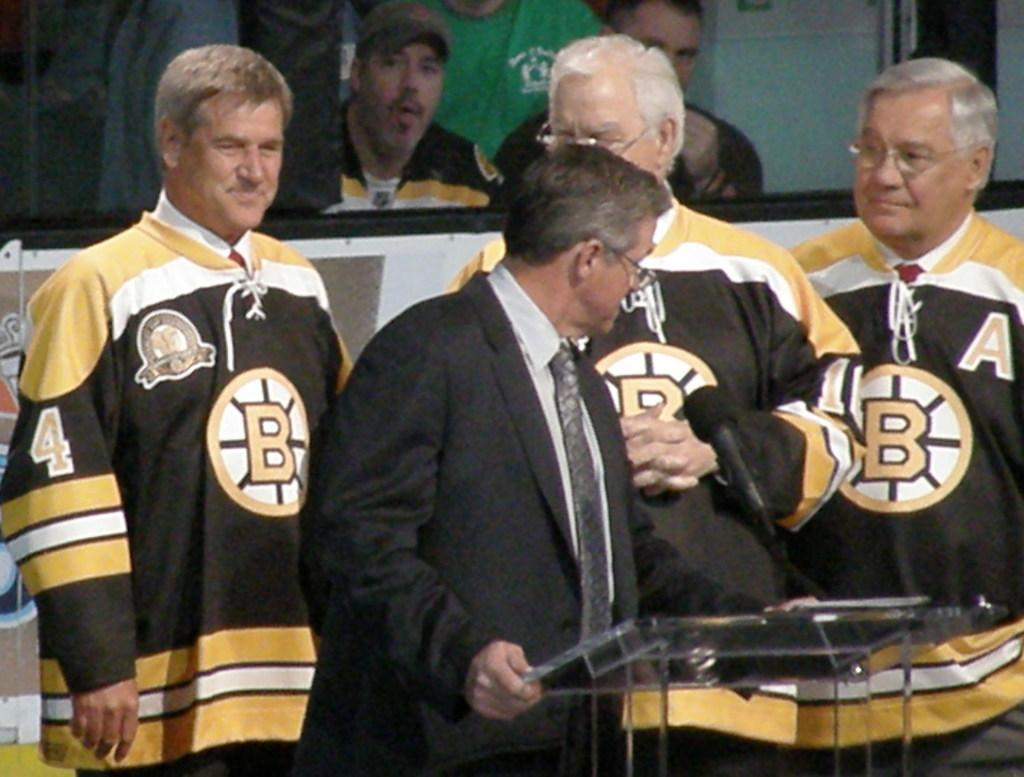<image>
Provide a brief description of the given image. a series of hockey players with the letter A on their jersey 